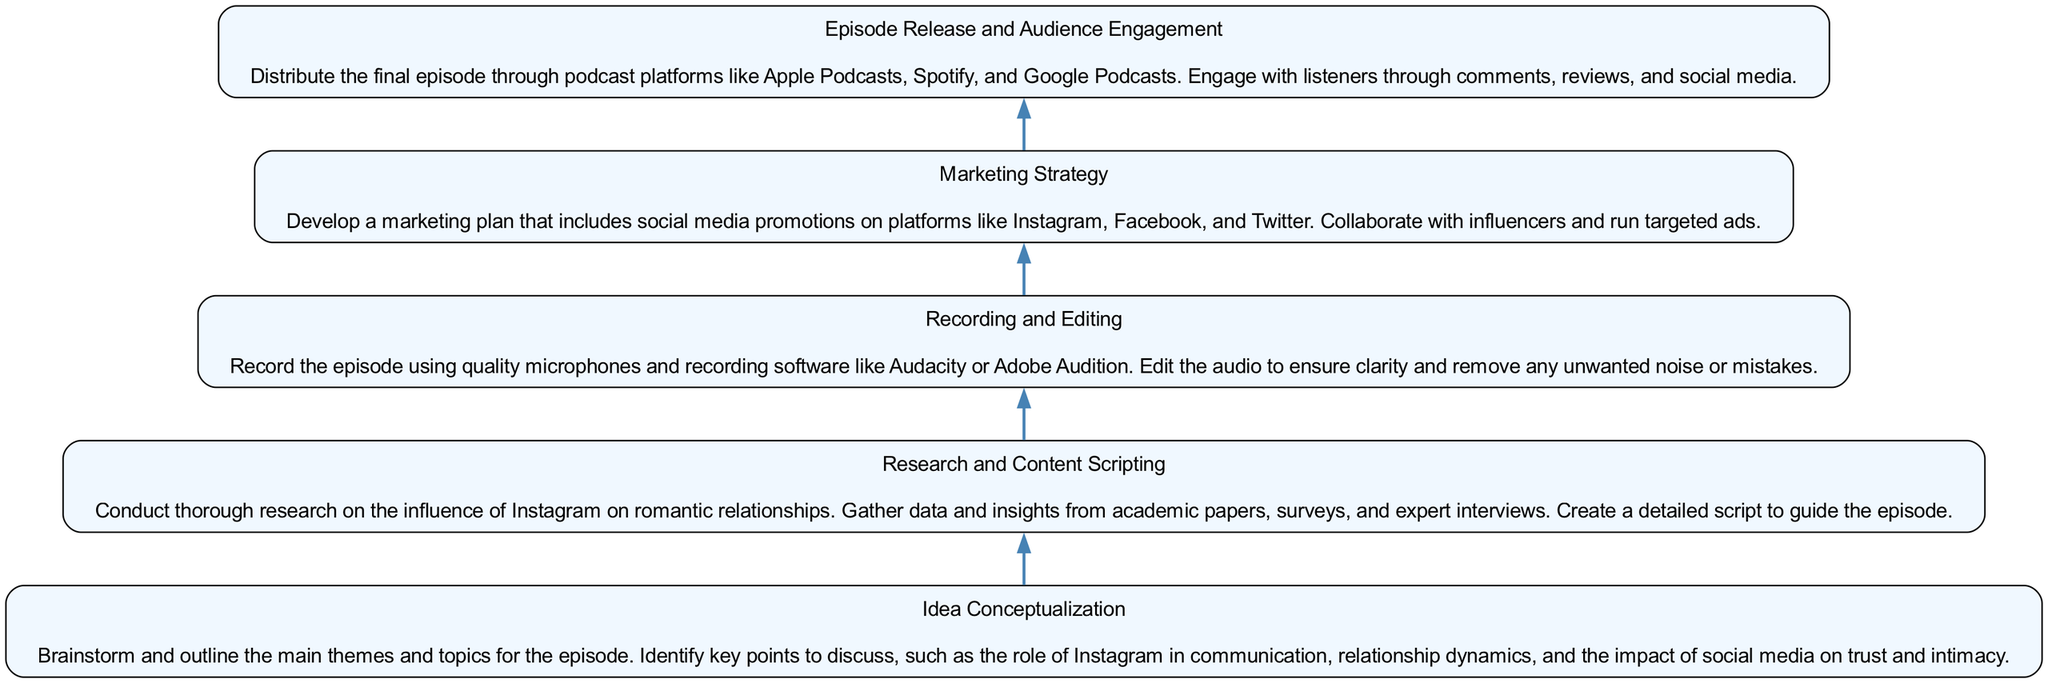What is the first step in the podcast creation process? The first step, when looking at the flow from bottom to top, is "Idea Conceptualization." It represents the starting phase where themes and topics for the episode are brainstormed.
Answer: Idea Conceptualization How many steps are there in the podcast creation process? By counting each individual step from the bottom of the diagram to the top, there are five distinct steps. Each of these corresponds to an essential part of the podcast episode creation process.
Answer: 5 What does the "Recording and Editing" step involve? The "Recording and Editing" step involves recording the episode using quality microphones and software, then editing it to ensure clarity and remove unwanted noise or mistakes. This detail is included within the description of that step.
Answer: Record and edit audio Which step follows "Research and Content Scripting"? Looking at the directed flow from bottom to up, the step that follows "Research and Content Scripting" is "Recording and Editing." This indicates that content must be scripted before recording can take place.
Answer: Recording and Editing How is audience engagement handled after the episode release? Audience engagement is managed by distributing the final episode through various podcast platforms and interacting with listeners via comments, reviews, and social media, as mentioned in the description of "Episode Release and Audience Engagement."
Answer: Comments and social media What is the primary purpose of the "Marketing Strategy" step? The main purpose of the "Marketing Strategy" step is to develop a marketing plan that includes collaborations on social media platforms and targeted ads to promote the episode. This shows the strategic approach to reaching an audience.
Answer: Develop marketing plan What is the last step before episode release? The last step before episode release, when viewed from bottom to top, is "Marketing Strategy." It emphasizes the importance of promoting the podcast episode to maximize audience reach prior to its release.
Answer: Marketing Strategy What key aspects are brainstormed in "Idea Conceptualization"? In "Idea Conceptualization," key aspects such as the role of Instagram in communication and its impact on trust and intimacy in relationships are identified as main themes for discussion in the episode.
Answer: Main themes and topics What types of platforms are mentioned for distributing the episode? The platforms mentioned for distributing the episode include Apple Podcasts, Spotify, and Google Podcasts, which indicates where listeners can access the content after its release.
Answer: Podcast platforms 